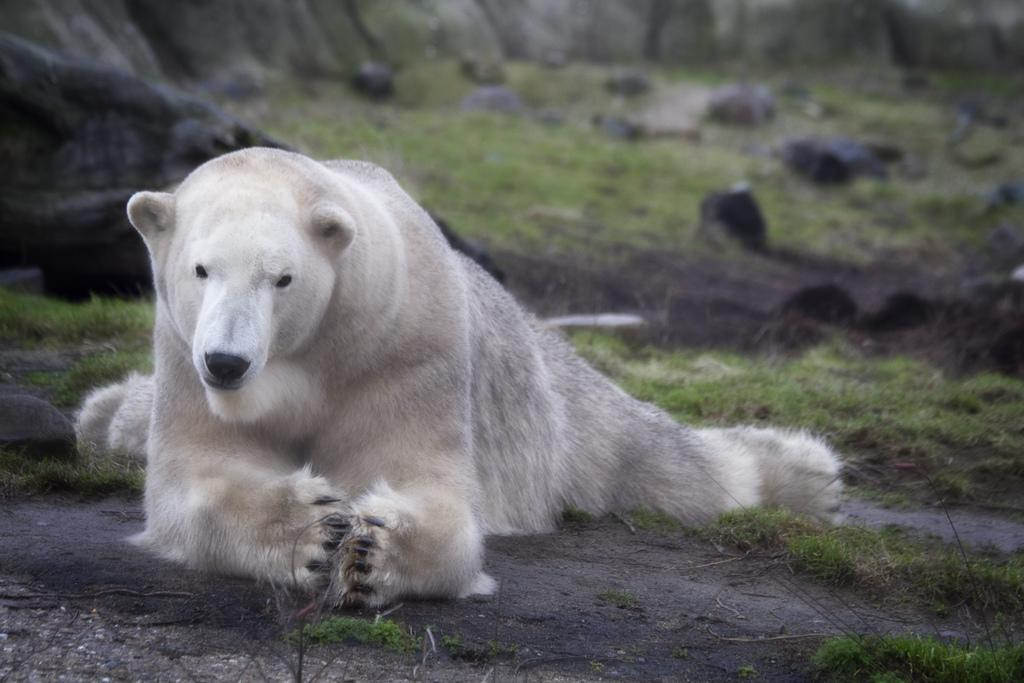What animal is the main subject of the image? There is a polar bear in the image. What is the polar bear doing in the image? The polar bear is lying on the ground. What type of terrain is visible in the image? There are rocks and grass on the ground. What type of class is the polar bear attending in the image? There is no indication in the image that the polar bear is attending a class. 